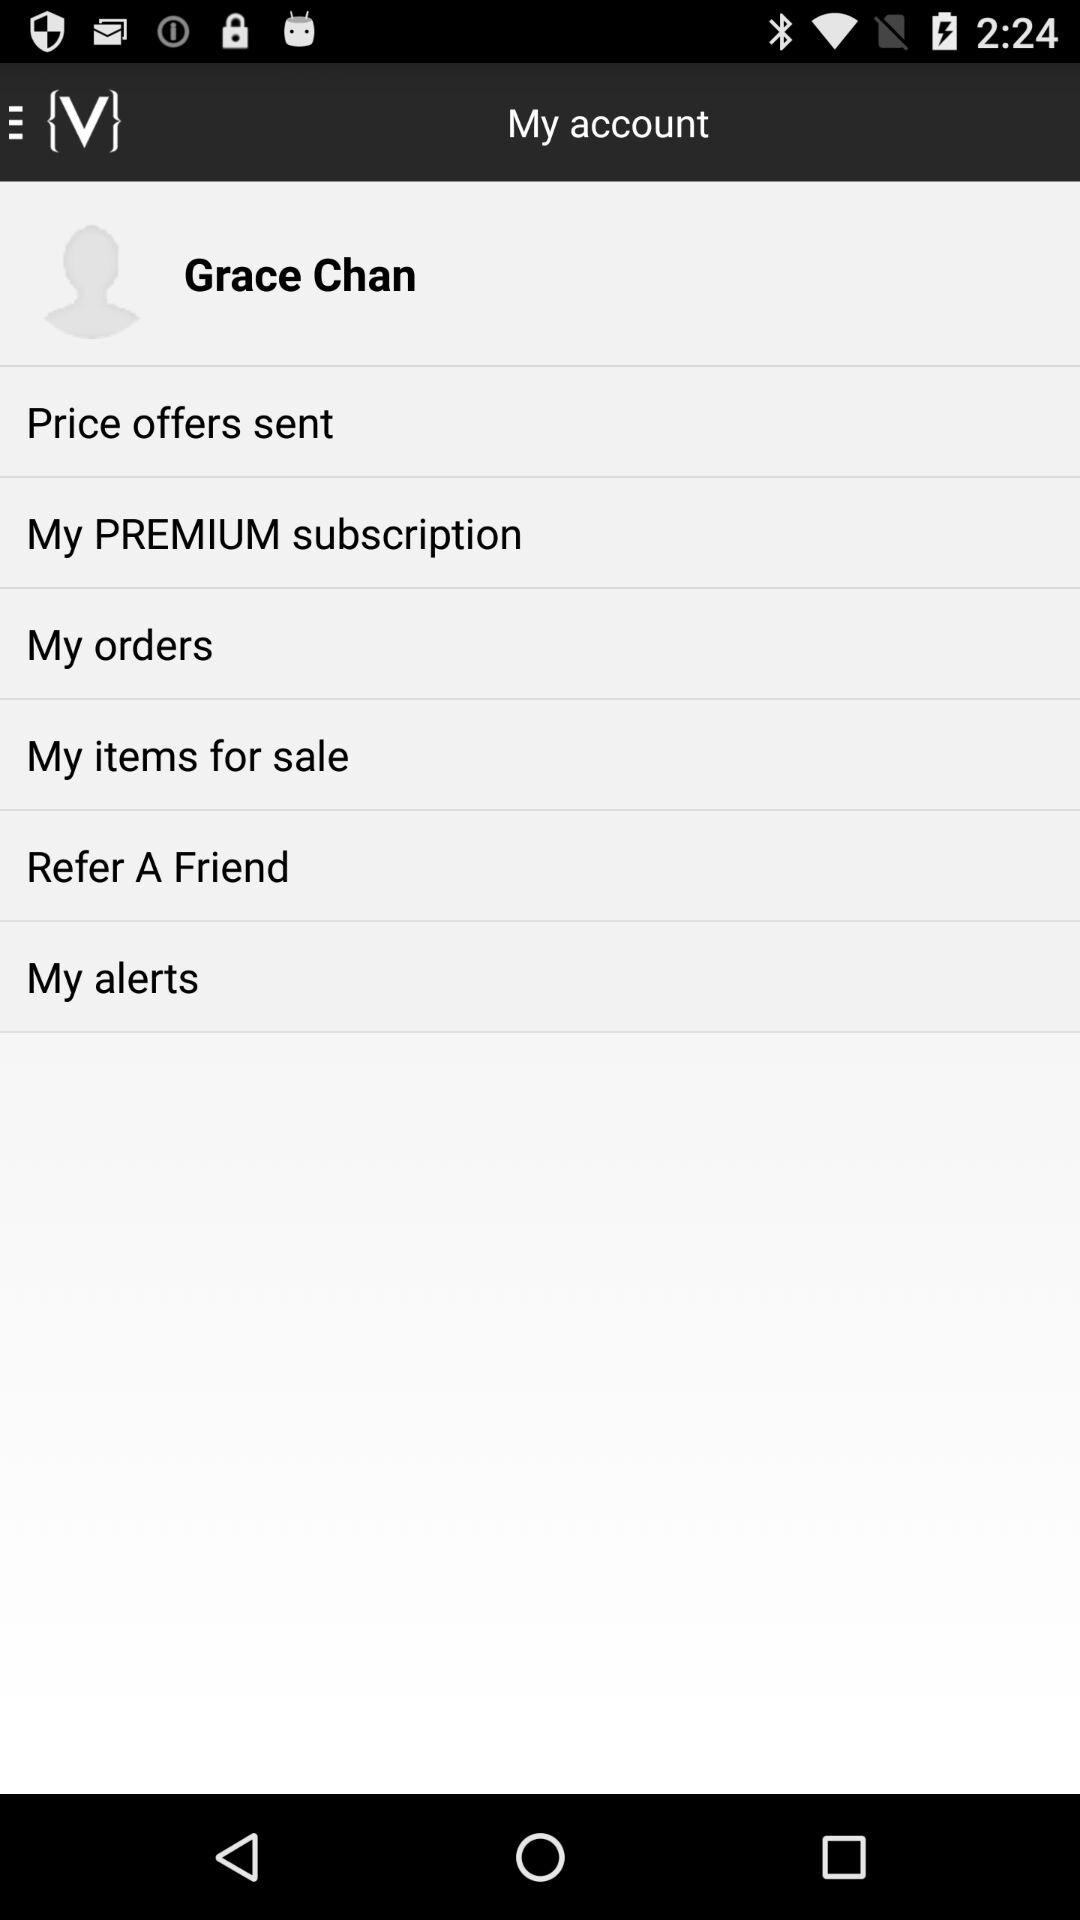How many items are in the My account menu?
Answer the question using a single word or phrase. 6 